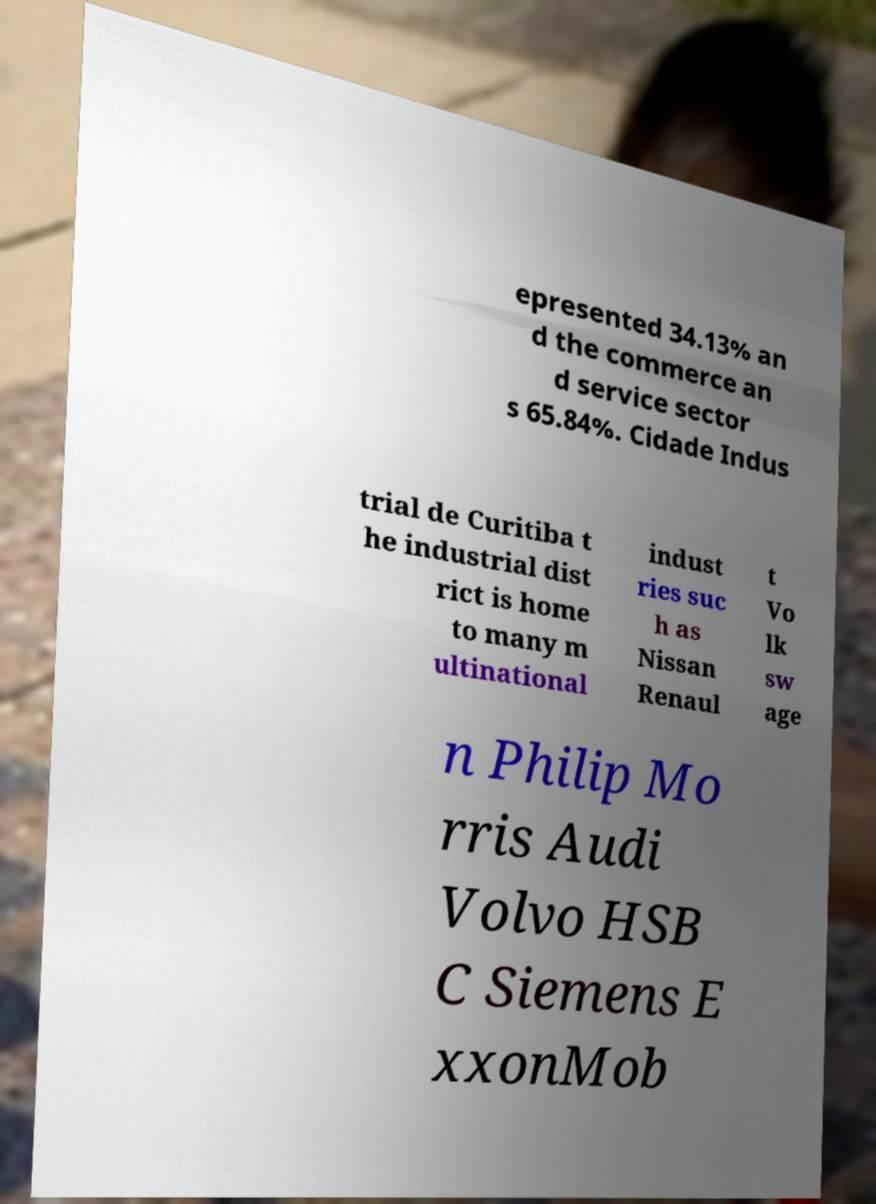Please read and relay the text visible in this image. What does it say? epresented 34.13% an d the commerce an d service sector s 65.84%. Cidade Indus trial de Curitiba t he industrial dist rict is home to many m ultinational indust ries suc h as Nissan Renaul t Vo lk sw age n Philip Mo rris Audi Volvo HSB C Siemens E xxonMob 